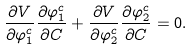<formula> <loc_0><loc_0><loc_500><loc_500>\frac { \partial V } { \partial \varphi ^ { c } _ { 1 } } \frac { \partial \varphi ^ { c } _ { 1 } } { \partial C } + \frac { \partial V } { \partial \varphi ^ { c } _ { 2 } } \frac { \partial \varphi ^ { c } _ { 2 } } { \partial C } = 0 .</formula> 